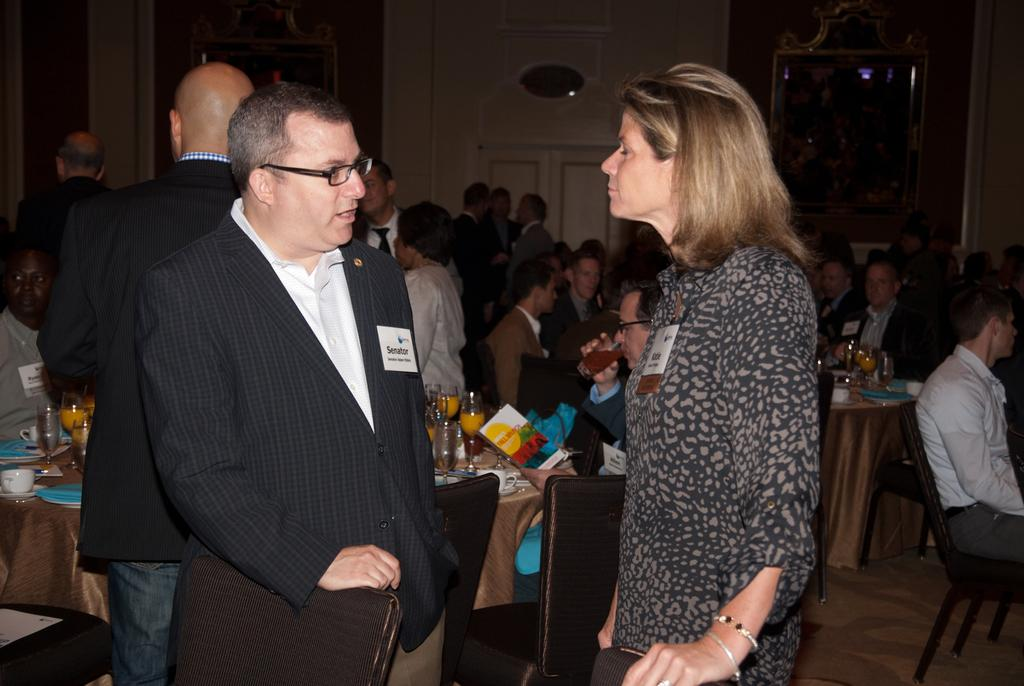How many people are in the image? There is a group of people in the image. What are some of the positions of the people in the image? Some people are standing, and some people are sitting on chairs. What is on the table in the image? There is a glass, a plate, a cup, a saucer, and a tissue on the table. What type of wrench is being used by someone in the image? There is no wrench present in the image. Can you describe the spot where the group of people is standing in the image? The provided facts do not mention a specific spot where the group of people is standing; only that they are in the image. 